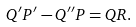Convert formula to latex. <formula><loc_0><loc_0><loc_500><loc_500>Q ^ { \prime } P ^ { \prime } - Q ^ { \prime \prime } P = Q R .</formula> 